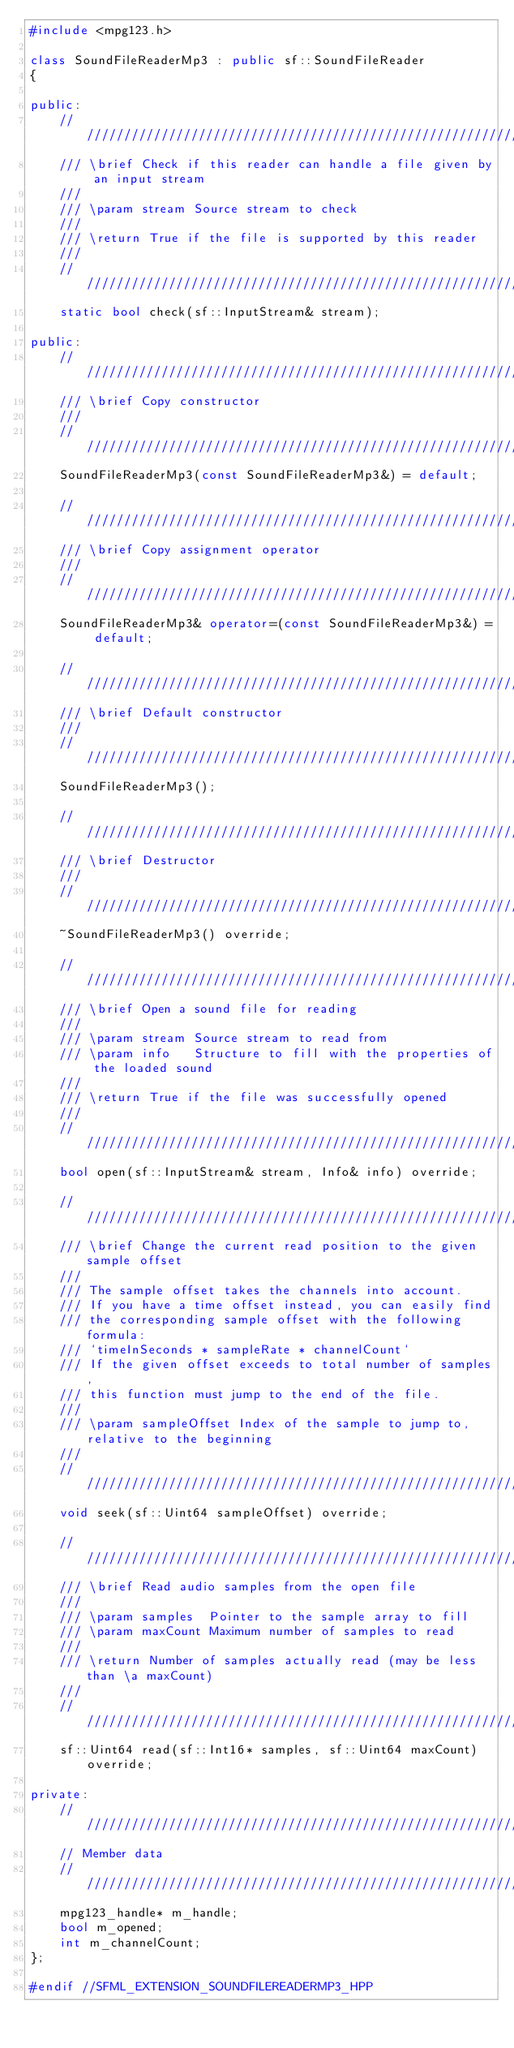Convert code to text. <code><loc_0><loc_0><loc_500><loc_500><_C++_>#include <mpg123.h>

class SoundFileReaderMp3 : public sf::SoundFileReader
{

public:
	////////////////////////////////////////////////////////////
	/// \brief Check if this reader can handle a file given by an input stream
	///
	/// \param stream Source stream to check
	///
	/// \return True if the file is supported by this reader
	///
	////////////////////////////////////////////////////////////
	static bool check(sf::InputStream& stream);

public:
	////////////////////////////////////////////////////////////
	/// \brief Copy constructor
	///
	////////////////////////////////////////////////////////////
	SoundFileReaderMp3(const SoundFileReaderMp3&) = default;

	////////////////////////////////////////////////////////////
	/// \brief Copy assignment operator
	///
	////////////////////////////////////////////////////////////
	SoundFileReaderMp3& operator=(const SoundFileReaderMp3&) = default;

	////////////////////////////////////////////////////////////
	/// \brief Default constructor
	///
	////////////////////////////////////////////////////////////
	SoundFileReaderMp3();

	////////////////////////////////////////////////////////////
	/// \brief Destructor
	///
	////////////////////////////////////////////////////////////
	~SoundFileReaderMp3() override;

	////////////////////////////////////////////////////////////
	/// \brief Open a sound file for reading
	///
	/// \param stream Source stream to read from
	/// \param info   Structure to fill with the properties of the loaded sound
	///
	/// \return True if the file was successfully opened
	///
	////////////////////////////////////////////////////////////
	bool open(sf::InputStream& stream, Info& info) override;

	////////////////////////////////////////////////////////////
	/// \brief Change the current read position to the given sample offset
	///
	/// The sample offset takes the channels into account.
	/// If you have a time offset instead, you can easily find
	/// the corresponding sample offset with the following formula:
	/// `timeInSeconds * sampleRate * channelCount`
	/// If the given offset exceeds to total number of samples,
	/// this function must jump to the end of the file.
	///
	/// \param sampleOffset Index of the sample to jump to, relative to the beginning
	///
	////////////////////////////////////////////////////////////
	void seek(sf::Uint64 sampleOffset) override;

	////////////////////////////////////////////////////////////
	/// \brief Read audio samples from the open file
	///
	/// \param samples  Pointer to the sample array to fill
	/// \param maxCount Maximum number of samples to read
	///
	/// \return Number of samples actually read (may be less than \a maxCount)
	///
	////////////////////////////////////////////////////////////
	sf::Uint64 read(sf::Int16* samples, sf::Uint64 maxCount) override;

private:
	////////////////////////////////////////////////////////////
	// Member data
	////////////////////////////////////////////////////////////
	mpg123_handle* m_handle;
	bool m_opened;
	int m_channelCount;
};

#endif //SFML_EXTENSION_SOUNDFILEREADERMP3_HPP
</code> 